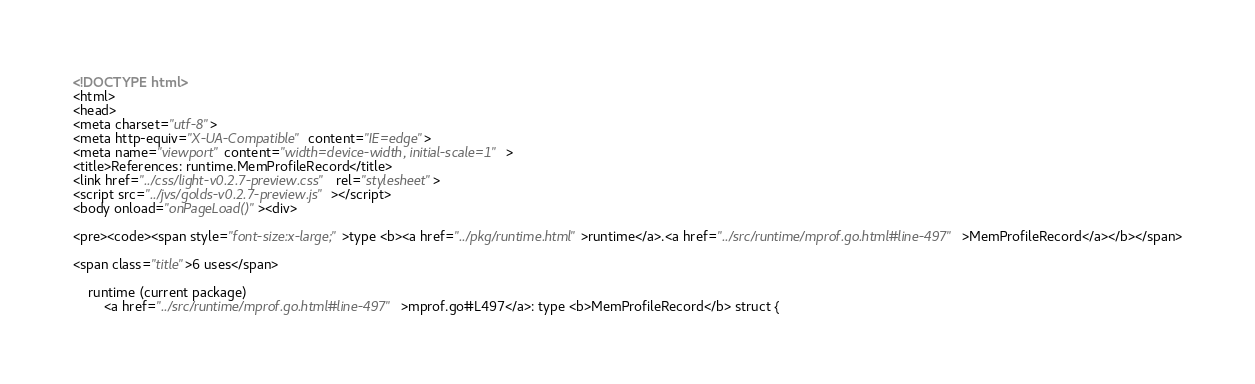Convert code to text. <code><loc_0><loc_0><loc_500><loc_500><_HTML_><!DOCTYPE html>
<html>
<head>
<meta charset="utf-8">
<meta http-equiv="X-UA-Compatible" content="IE=edge">
<meta name="viewport" content="width=device-width, initial-scale=1">
<title>References: runtime.MemProfileRecord</title>
<link href="../css/light-v0.2.7-preview.css" rel="stylesheet">
<script src="../jvs/golds-v0.2.7-preview.js"></script>
<body onload="onPageLoad()"><div>

<pre><code><span style="font-size:x-large;">type <b><a href="../pkg/runtime.html">runtime</a>.<a href="../src/runtime/mprof.go.html#line-497">MemProfileRecord</a></b></span>

<span class="title">6 uses</span>

	runtime (current package)
		<a href="../src/runtime/mprof.go.html#line-497">mprof.go#L497</a>: type <b>MemProfileRecord</b> struct {</code> 